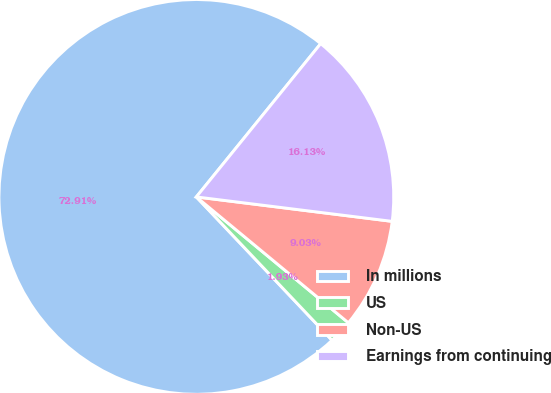Convert chart. <chart><loc_0><loc_0><loc_500><loc_500><pie_chart><fcel>In millions<fcel>US<fcel>Non-US<fcel>Earnings from continuing<nl><fcel>72.92%<fcel>1.93%<fcel>9.03%<fcel>16.13%<nl></chart> 